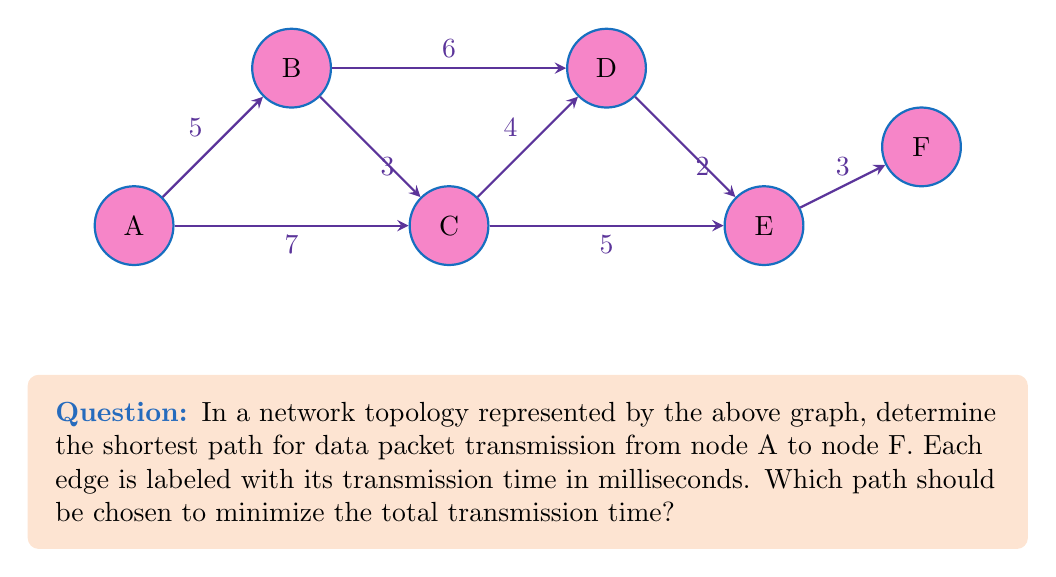Help me with this question. To find the optimal path for data packet transmission, we need to calculate the total transmission time for all possible paths from A to F and choose the one with the minimum total time. Let's break this down step-by-step:

1. Identify all possible paths from A to F:
   Path 1: A → B → C → D → E → F
   Path 2: A → B → D → E → F
   Path 3: A → C → D → E → F
   Path 4: A → C → E → F

2. Calculate the total transmission time for each path:

   Path 1: 
   $T_1 = 5 + 3 + 4 + 2 + 3 = 17$ ms

   Path 2:
   $T_2 = 5 + 6 + 2 + 3 = 16$ ms

   Path 3:
   $T_3 = 7 + 4 + 2 + 3 = 16$ ms

   Path 4:
   $T_4 = 7 + 5 + 3 = 15$ ms

3. Compare the total transmission times:
   $T_4 < T_2 = T_3 < T_1$

4. The shortest path is Path 4 (A → C → E → F) with a total transmission time of 15 ms.

This problem demonstrates the importance of efficient routing in network topologies, which is crucial for optimizing server-side performance and database management in distributed systems.
Answer: A → C → E → F 